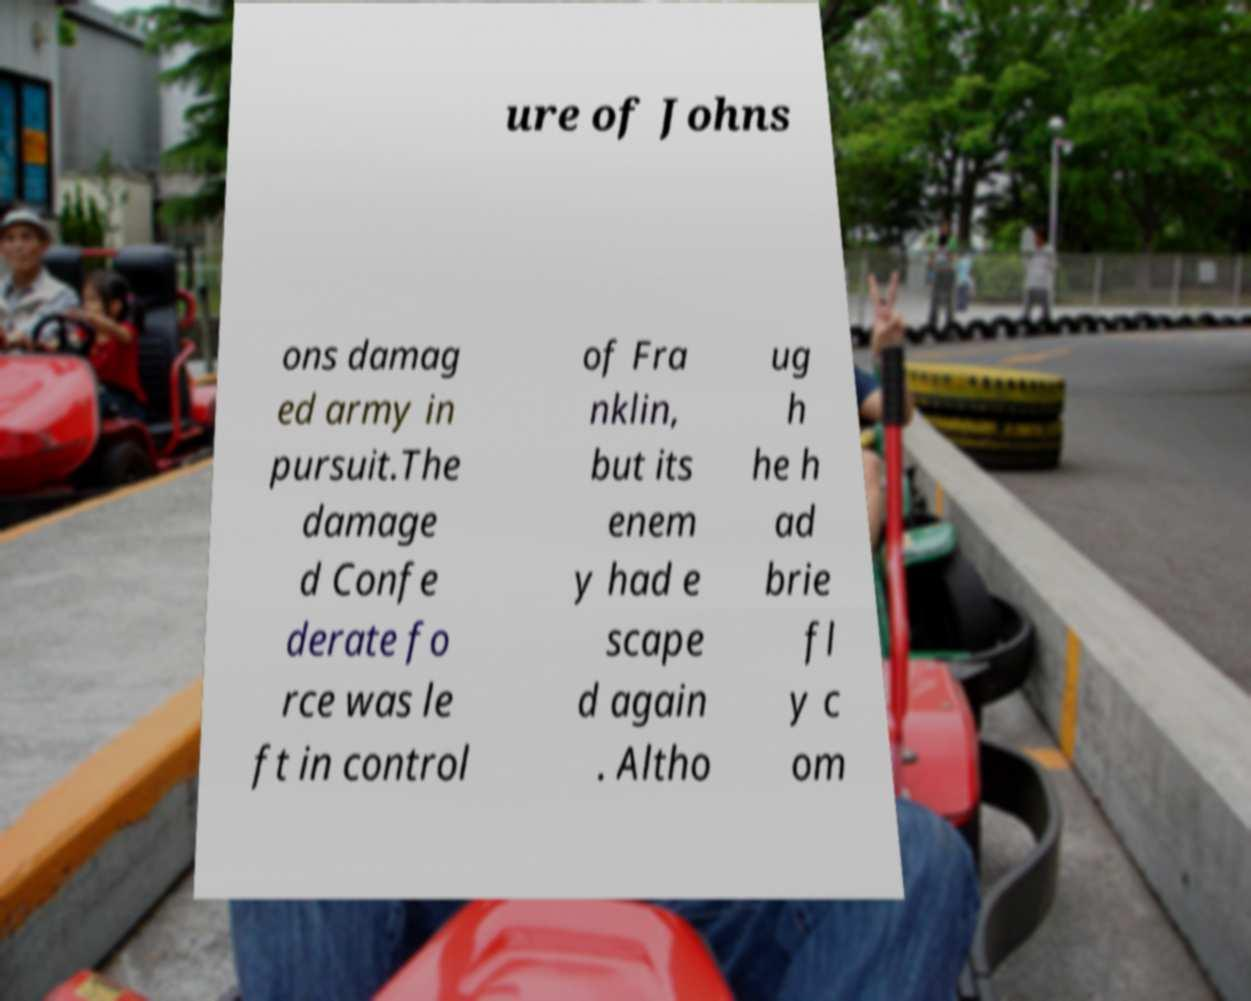Please identify and transcribe the text found in this image. ure of Johns ons damag ed army in pursuit.The damage d Confe derate fo rce was le ft in control of Fra nklin, but its enem y had e scape d again . Altho ug h he h ad brie fl y c om 